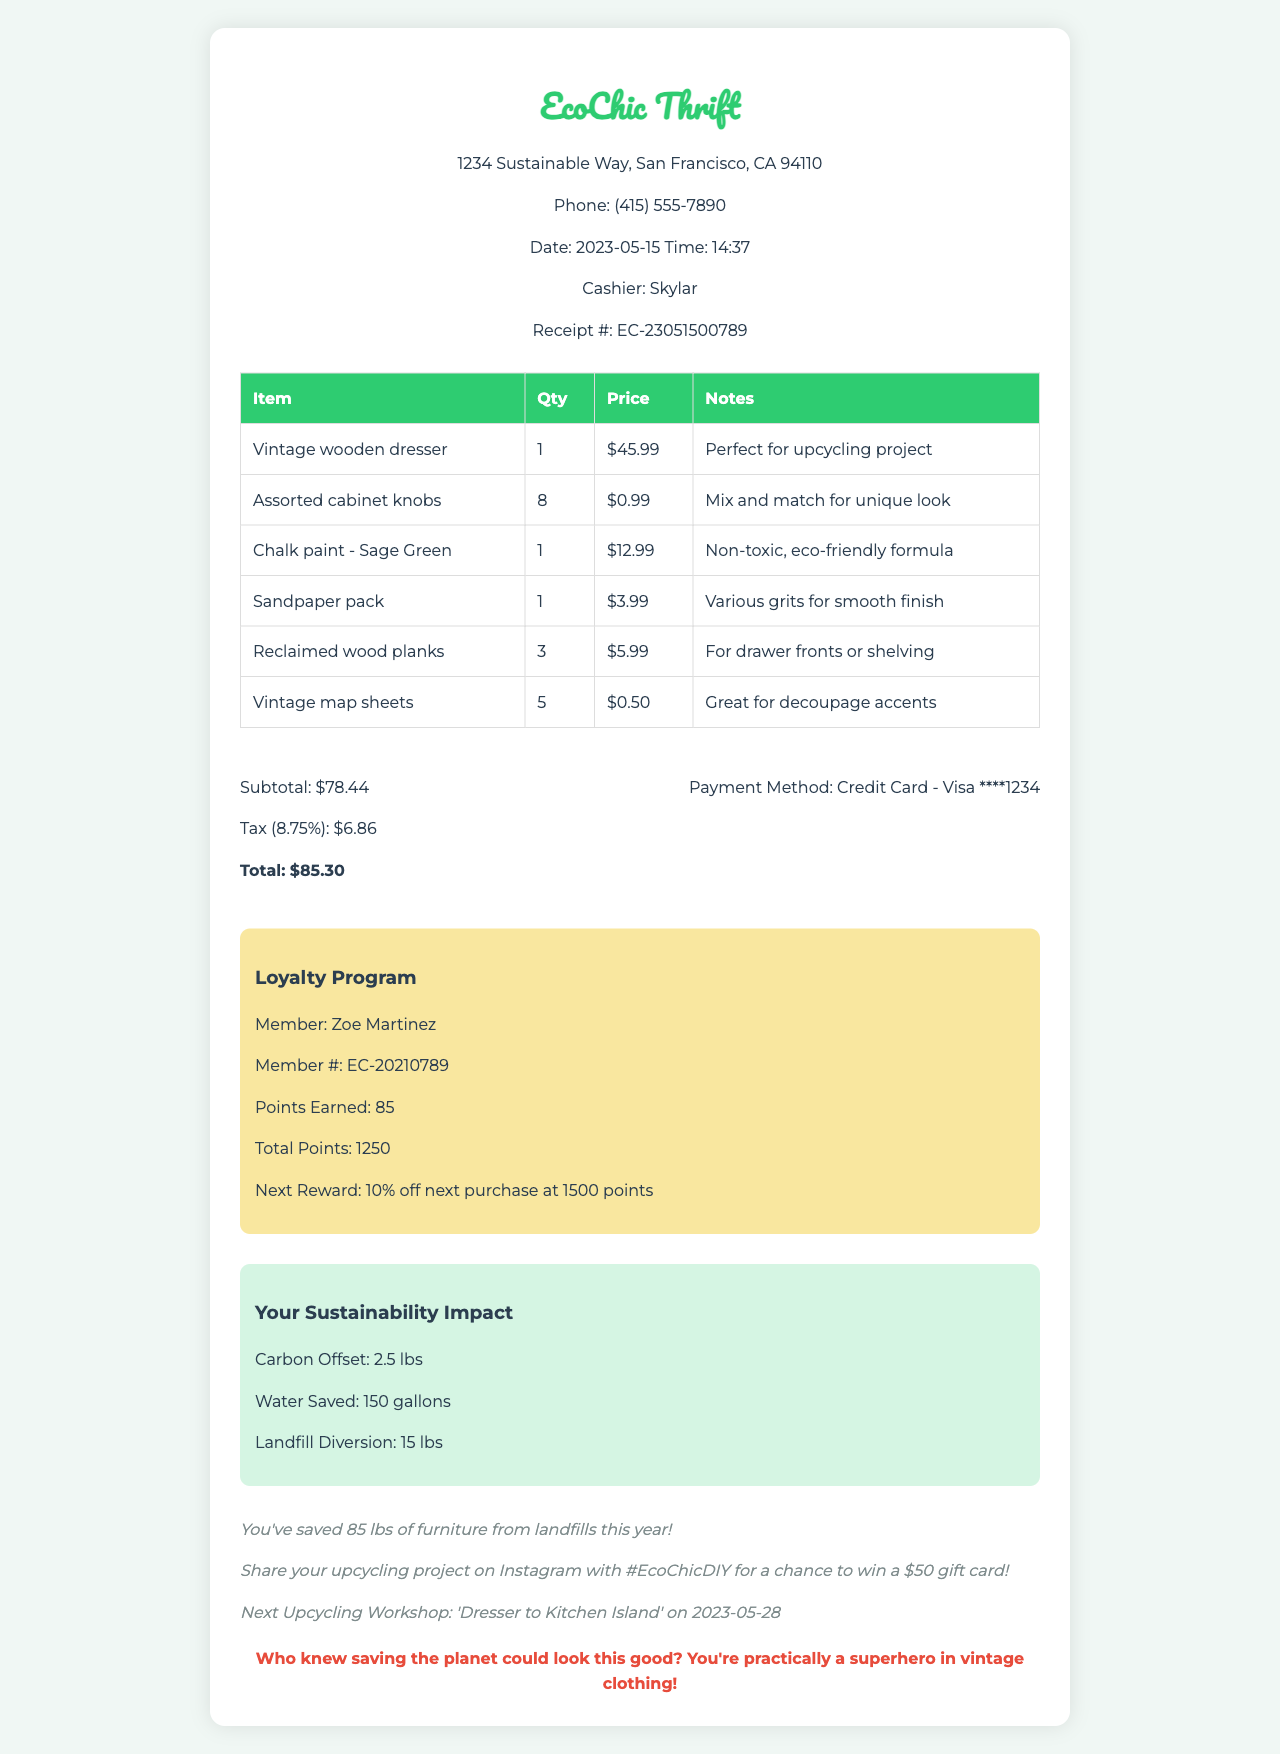What is the store name? The store name is found in the header of the receipt.
Answer: EcoChic Thrift What is the total amount spent? The total amount spent is at the bottom of the document after tax is applied.
Answer: $85.30 Who is the cashier? The cashier's name is provided in the header section.
Answer: Skylar How many vintage map sheets were purchased? The quantity of vintage map sheets can be found in the items list.
Answer: 5 What is the tax rate? The tax rate is specified along with the subtotal and tax amount.
Answer: 8.75% How many loyalty points did Zoe earn from this purchase? The points earned are indicated in the loyalty program section of the receipt.
Answer: 85 What is the next reward for Zoe in the loyalty program? The next reward is detailed in the loyalty program area.
Answer: 10% off next purchase at 1500 points What sustainability impact is mentioned regarding water? The sustainability impact section lists water savings.
Answer: 150 gallons What item is noted as "Perfect for upcycling project"? The notes column of the items table provides this information.
Answer: Vintage wooden dresser 